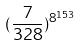<formula> <loc_0><loc_0><loc_500><loc_500>( \frac { 7 } { 3 2 8 } ) ^ { 8 ^ { 1 5 3 } }</formula> 